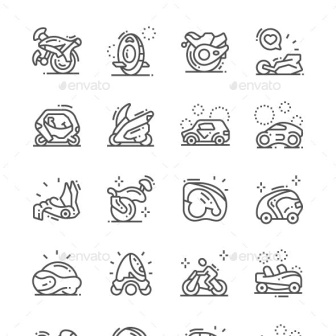Describe the following image. The image features an array of sixteen meticulously drawn black and white icons, each symbolizing a different form of transportation, lined up in a grid pattern of four rows. From traditional to modern, these icons include a bicycle, compass, rocket, sled, car, snowmobile, sedan, motorcycle, skateboard, jet ski, surfboard, and a scooter. Each icon, executed in a minimalist line art style, not only displays a mode of transportation but also invites viewers to reflect on the various ways people traverse and explore the world around them. The arrangement and simple aesthetic provide a visually pleasing overview of transportation options, ranging from everyday vehicles to those meant for leisure and extreme conditions. 